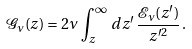<formula> <loc_0><loc_0><loc_500><loc_500>\mathcal { G } _ { \nu } ( z ) = 2 \nu \, \int _ { z } ^ { \infty } \, d z ^ { \prime } \, \frac { \mathcal { E } _ { \nu } ( z ^ { \prime } ) } { z ^ { \prime 2 } } \, .</formula> 